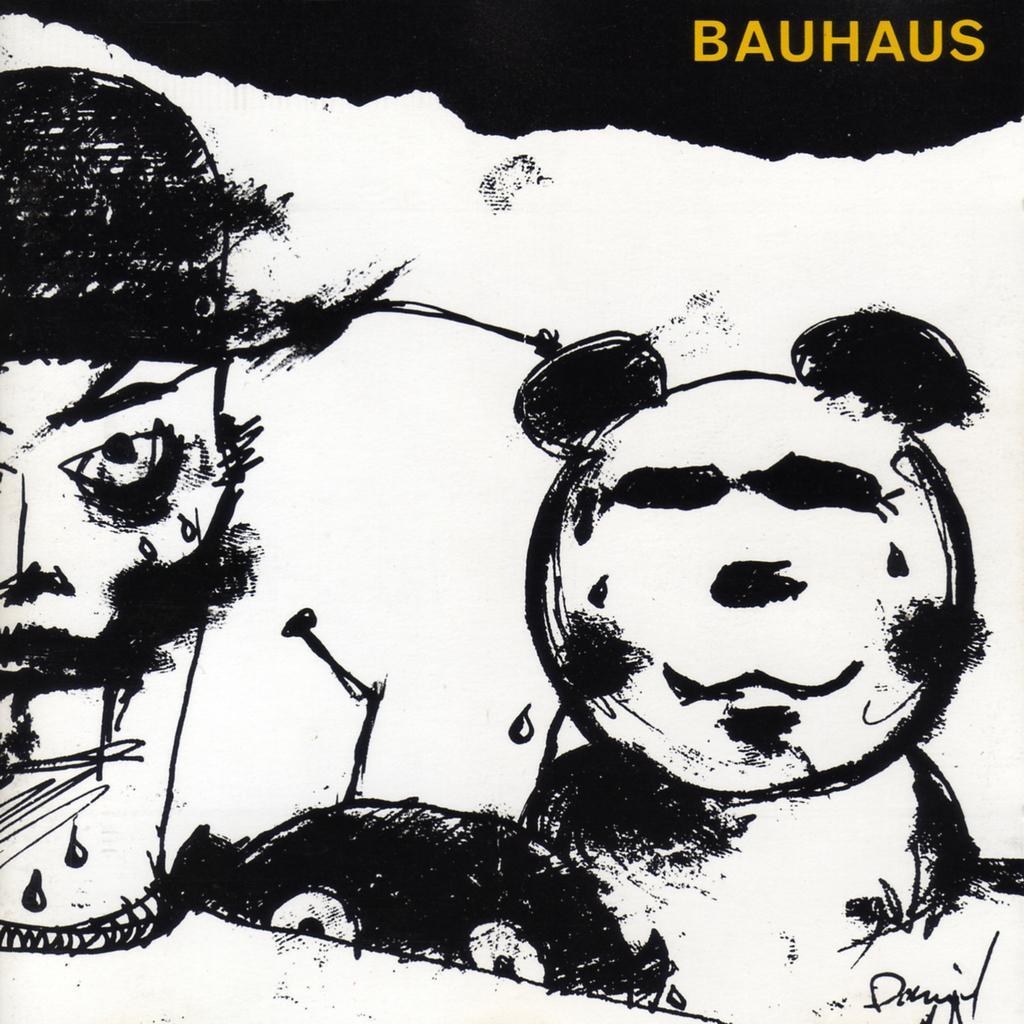Could you give a brief overview of what you see in this image? In this image a paining and a text. 